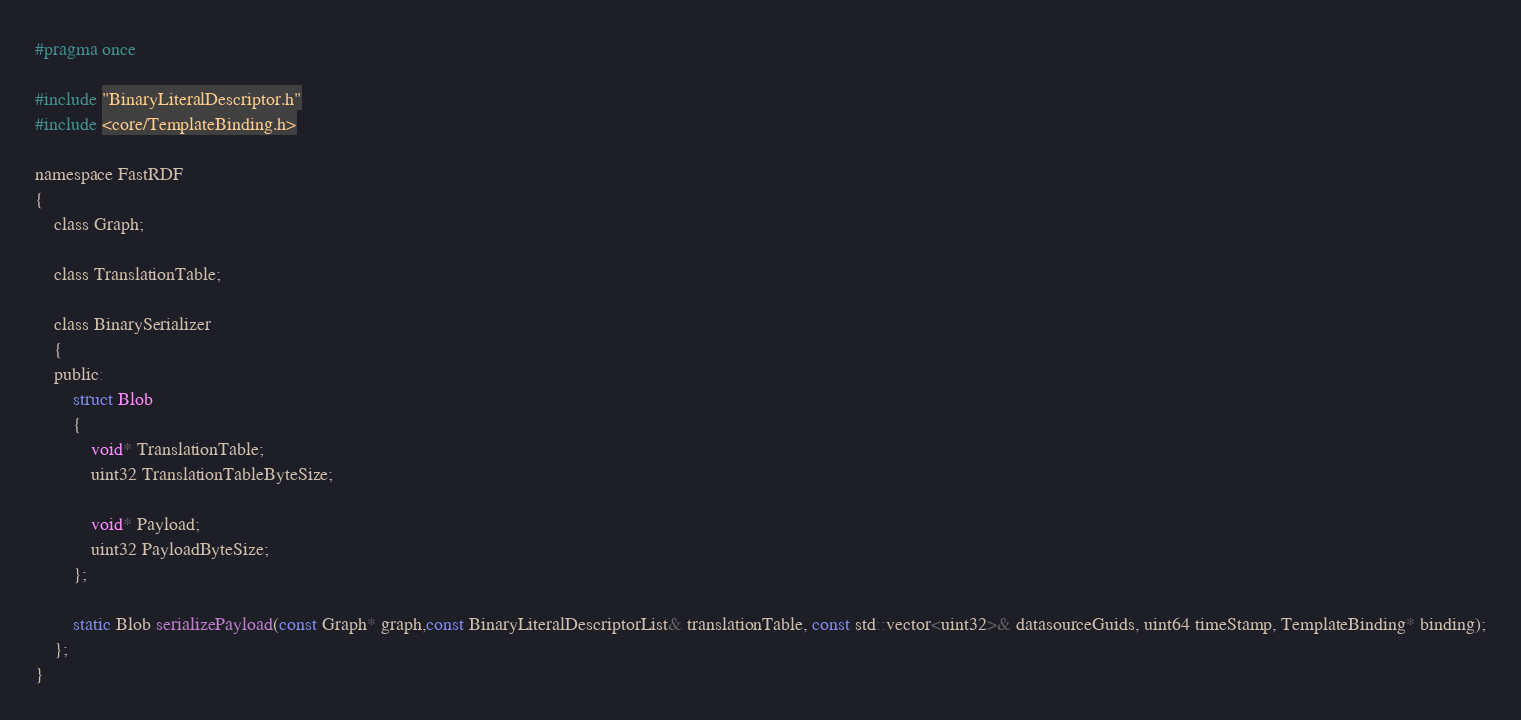<code> <loc_0><loc_0><loc_500><loc_500><_C_>#pragma once

#include "BinaryLiteralDescriptor.h"
#include <core/TemplateBinding.h>

namespace FastRDF
{
	class Graph;

	class TranslationTable;

	class BinarySerializer
	{
	public:
		struct Blob
		{
			void* TranslationTable;
			uint32 TranslationTableByteSize;

			void* Payload;
			uint32 PayloadByteSize;
		};

		static Blob serializePayload(const Graph* graph,const BinaryLiteralDescriptorList& translationTable, const std::vector<uint32>& datasourceGuids, uint64 timeStamp, TemplateBinding* binding);
	};
}</code> 